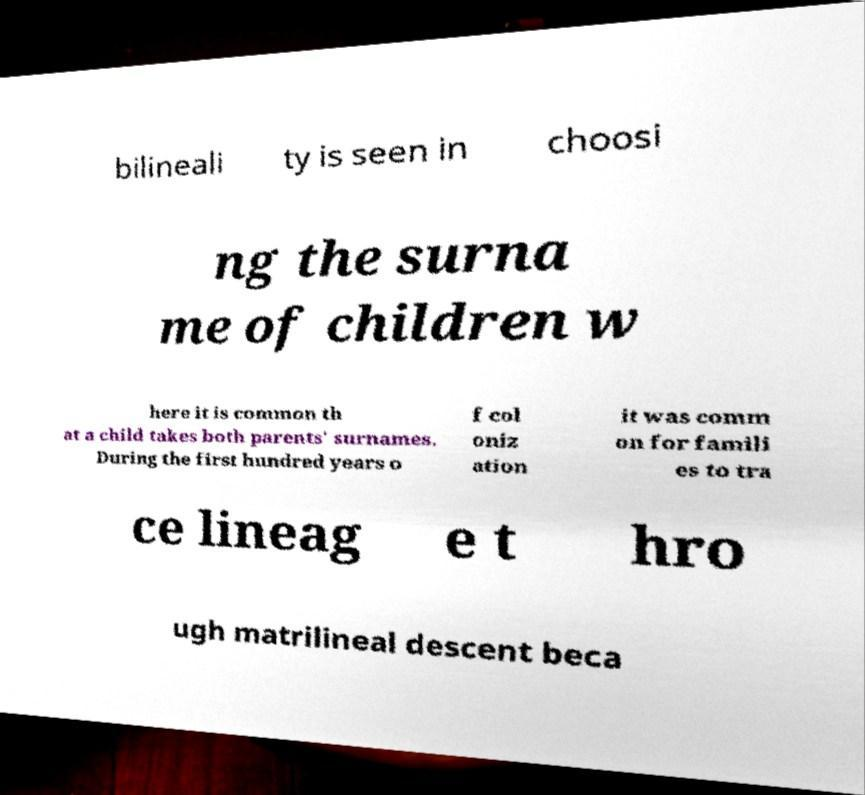For documentation purposes, I need the text within this image transcribed. Could you provide that? bilineali ty is seen in choosi ng the surna me of children w here it is common th at a child takes both parents' surnames. During the first hundred years o f col oniz ation it was comm on for famili es to tra ce lineag e t hro ugh matrilineal descent beca 